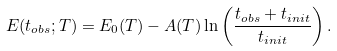Convert formula to latex. <formula><loc_0><loc_0><loc_500><loc_500>E ( t _ { o b s } ; T ) = E _ { 0 } ( T ) - A ( T ) \ln \left ( \frac { t _ { o b s } + t _ { i n i t } } { t _ { i n i t } } \right ) .</formula> 